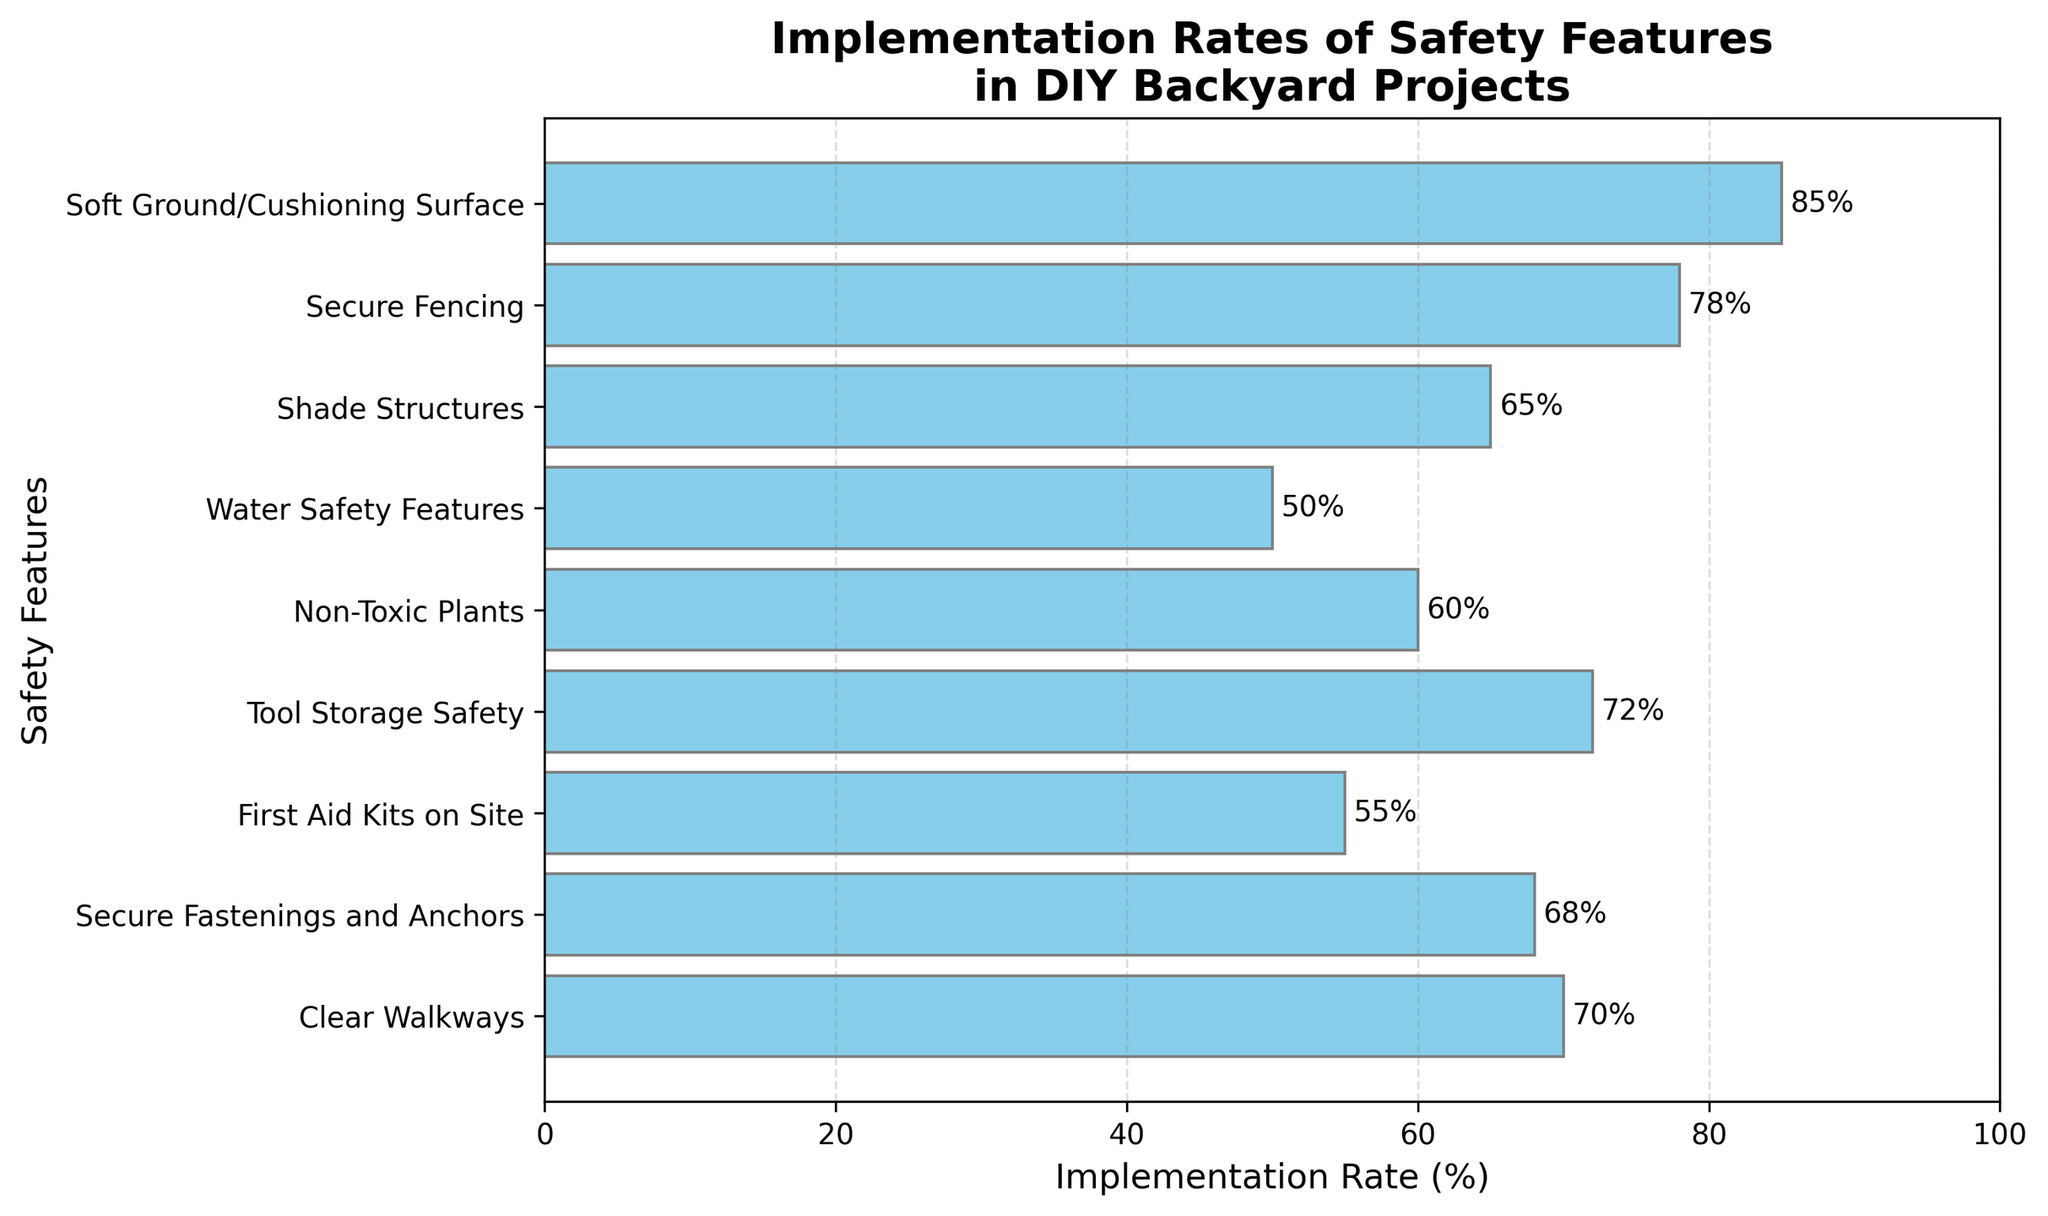What safety feature has the highest implementation rate? The bar chart shows the features and their implementation rates. The feature with the longest bar represents the highest rate. "Soft Ground/Cushioning Surface" has the longest bar and thus the highest implementation rate.
Answer: Soft Ground/Cushioning Surface Which two safety features have the closest implementation rates, and what are those rates? By observing the bar lengths, we note that "Non-Toxic Plants" and "First Aid Kits on Site" have implementation rates closest to each other. Their rates are 60% and 55% respectively.
Answer: Non-Toxic Plants (60%), First Aid Kits on Site (55%) Is "Tool Storage Safety" implemented more frequently than "Shade Structures"? The bar for "Tool Storage Safety" extends to 72% while "Shade Structures" extends to 65%. Since 72% is greater than 65%, "Tool Storage Safety" is implemented more frequently.
Answer: Yes What is the combined implementation rate of "Secure Fencing" and "Clear Walkways"? We add the implementation rates of "Secure Fencing" (78%) and "Clear Walkways" (70%). 78% + 70% = 148%.
Answer: 148% By what percentage does "Soft Ground/Cushioning Surface" exceed "Water Safety Features"? We subtract the implementation rate of "Water Safety Features" (50%) from that of "Soft Ground/Cushioning Surface" (85%). 85% - 50% = 35%.
Answer: 35% Which safety features have an implementation rate above 60%? Reviewing the chart, the features with implementation rates above 60% are "Soft Ground/Cushioning Surface" (85%), "Secure Fencing" (78%), "Shade Structures" (65%), "Tool Storage Safety" (72%), "Secure Fastenings and Anchors" (68%), and "Clear Walkways" (70%).
Answer: Soft Ground/Cushioning Surface, Secure Fencing, Shade Structures, Tool Storage Safety, Secure Fastenings and Anchors, Clear Walkways What is the average implementation rate across all safety features? To find the average rate, sum the implementation rates and divide by the number of features. Sum = 85%+78%+65%+50%+60%+72%+55%+68%+70% = 603%. Number of features = 9. Average = 603% / 9 ≈ 67%.
Answer: 67% Which has a lower implementation rate: "First Aid Kits on Site" or "Water Safety Features"? From the chart, the bar for "Water Safety Features" reaches 50%, and "First Aid Kits on Site" reaches 55%. Since 50% is less than 55%, "Water Safety Features" has a lower implementation rate.
Answer: Water Safety Features How much more frequent is the implementation of "Clear Walkways" compared to "Non-Toxic Plants"? Subtract the implementation rate of "Non-Toxic Plants" (60%) from that of "Clear Walkways" (70%). 70% - 60% = 10%.
Answer: 10% What is the range of implementation rates across all safety features? Identify the maximum (85% for "Soft Ground/Cushioning Surface") and minimum (50% for "Water Safety Features") implementation rates. Range = Maximum - Minimum. 85% - 50% = 35%.
Answer: 35% 